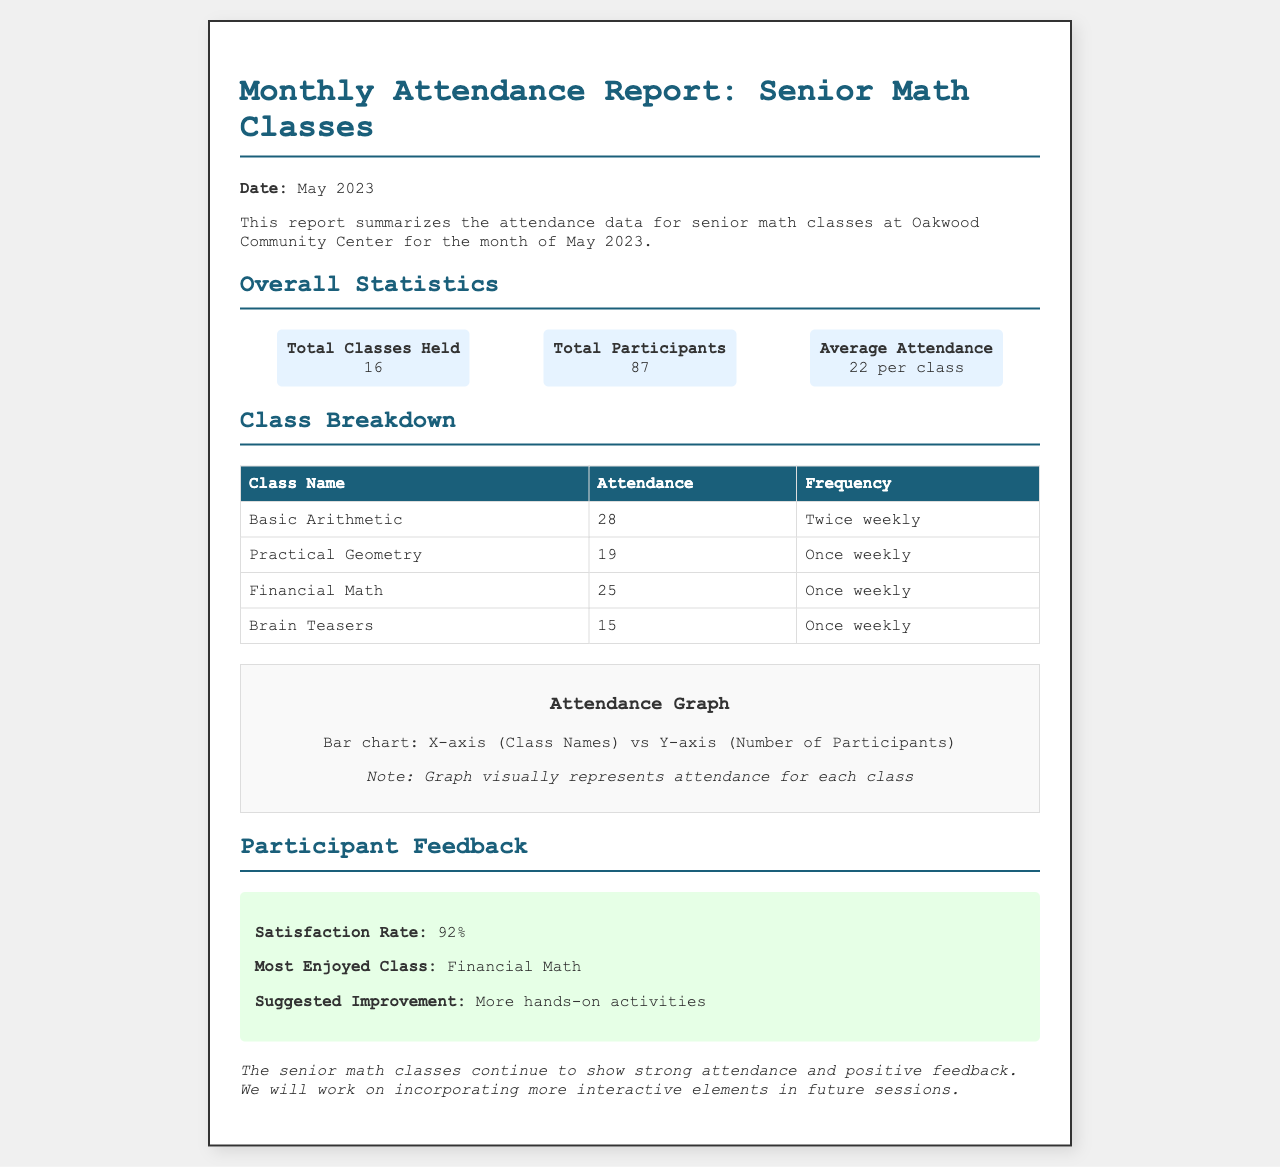What is the total number of classes held? The total number of classes held is stated in the report under Overall Statistics as 16.
Answer: 16 What is the average attendance per class? The average attendance is calculated as the total participants divided by total classes, which is shown as 22 per class.
Answer: 22 per class Which class had the highest attendance? The class with the highest attendance is indicated in the Class Breakdown section, which is Basic Arithmetic with an attendance of 28.
Answer: Basic Arithmetic What is the satisfaction rate from participant feedback? The satisfaction rate is explicitly mentioned in the Participant Feedback section as 92%.
Answer: 92% How many participants attended the Financial Math class? The number of participants for the Financial Math class is provided in the Class Breakdown as 25.
Answer: 25 What improvement was suggested by participants? The suggested improvement is highlighted in the feedback section as "More hands-on activities."
Answer: More hands-on activities How often does the Basic Arithmetic class meet? The frequency of the Basic Arithmetic class is found in the Class Breakdown as "Twice weekly."
Answer: Twice weekly What was the most enjoyed class according to participant feedback? The report specifies the most enjoyed class under Participant Feedback as Financial Math.
Answer: Financial Math 